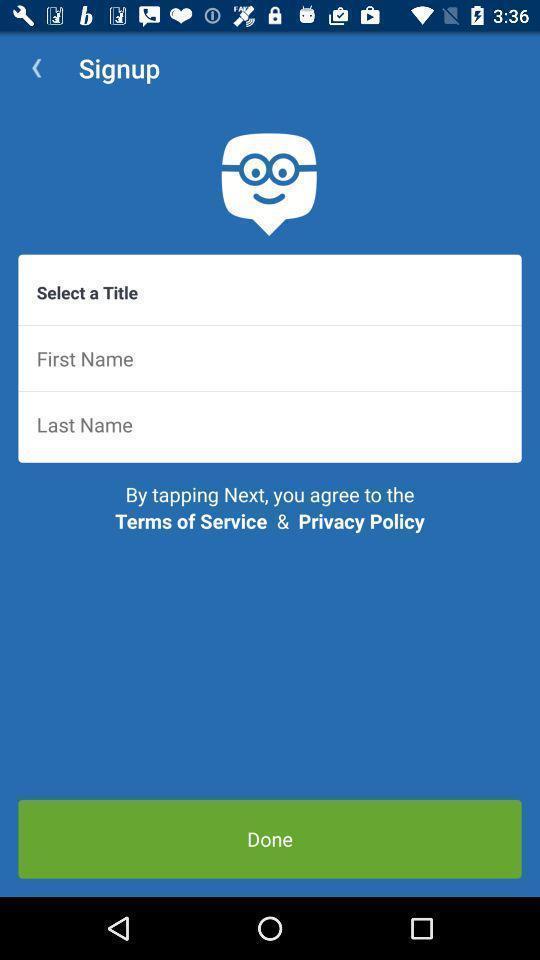Explain the elements present in this screenshot. Sign up page of education app. 